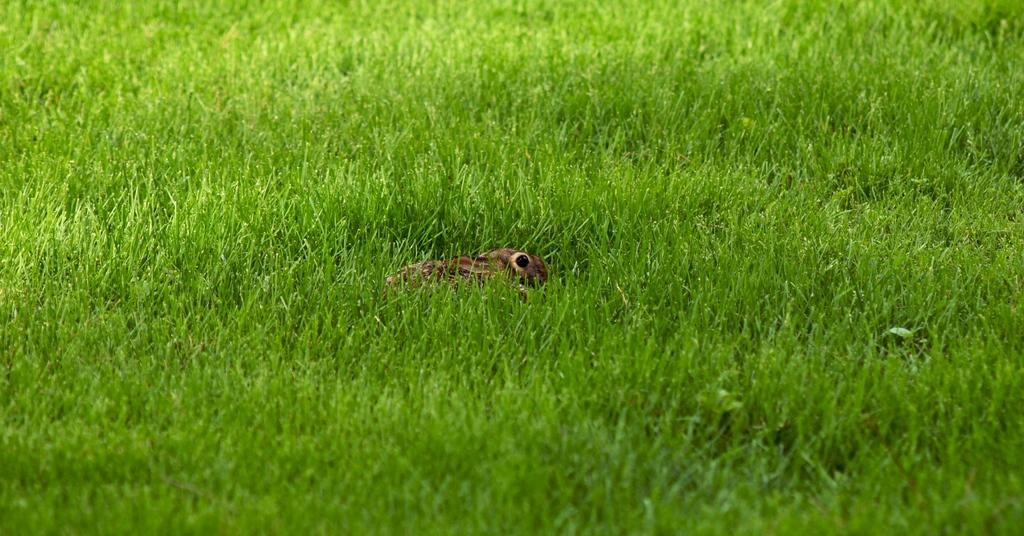What type of vegetation can be seen in the image? There is grass in the image. Is there anything else present in the grass? Yes, there appears to be an animal in the grass. What type of hammer is the animal using to build a house in the image? There is no hammer or house-building activity present in the image; it only features grass and an animal. 